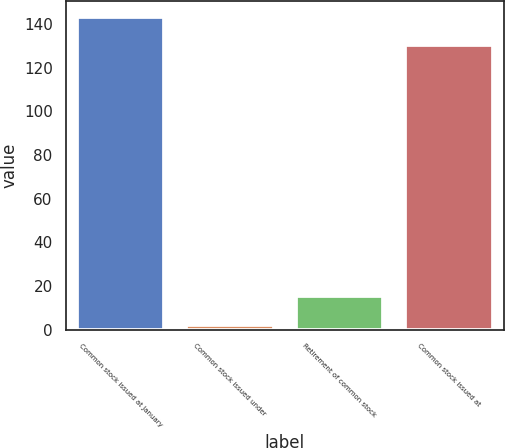Convert chart to OTSL. <chart><loc_0><loc_0><loc_500><loc_500><bar_chart><fcel>Common stock issued at January<fcel>Common stock issued under<fcel>Retirement of common stock<fcel>Common stock issued at<nl><fcel>143.35<fcel>2.2<fcel>15.25<fcel>130.3<nl></chart> 